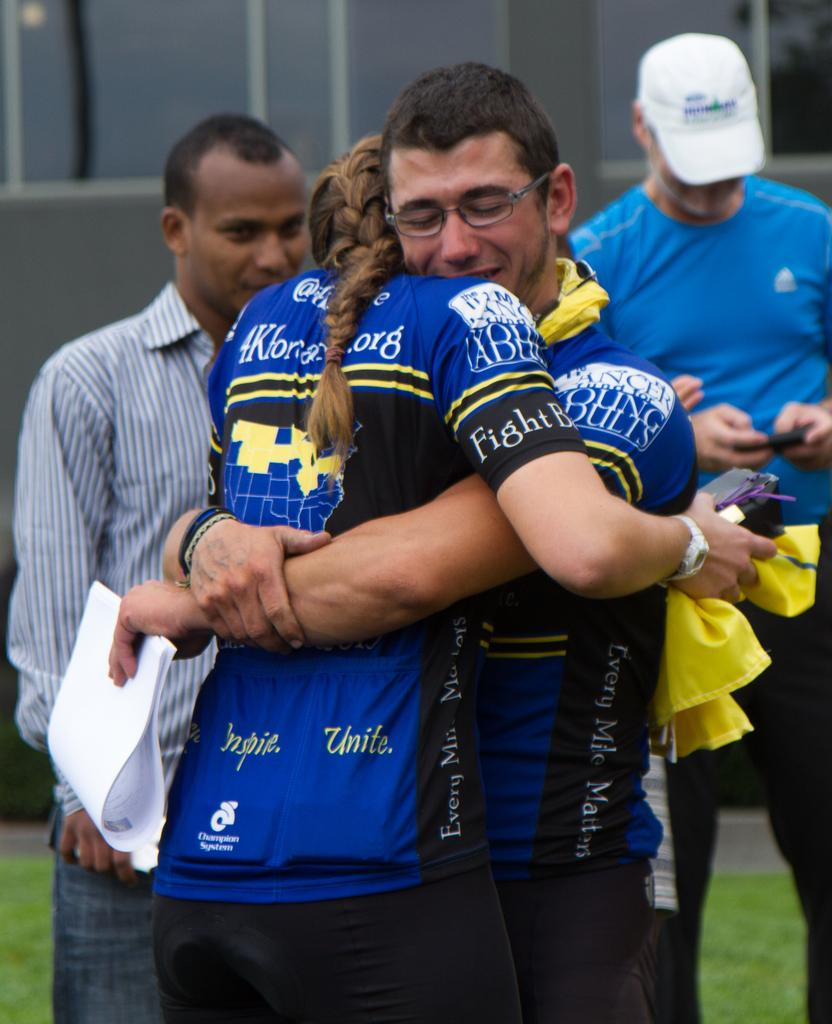<image>
Summarize the visual content of the image. A girl in a jersey with fight on the sleeve hugs another player. 